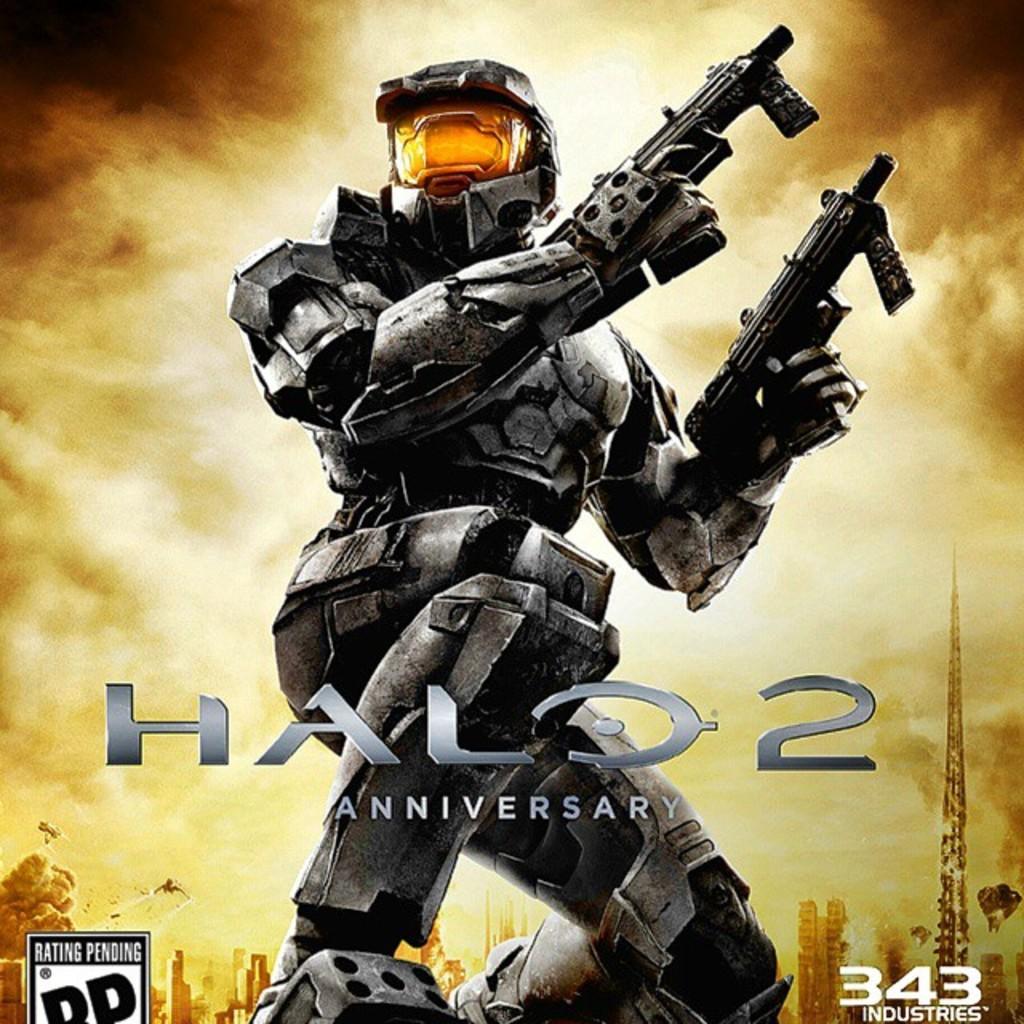What is the name of the video game here?
Provide a succinct answer. Halo 2. What number is written in white?
Provide a succinct answer. 343. 